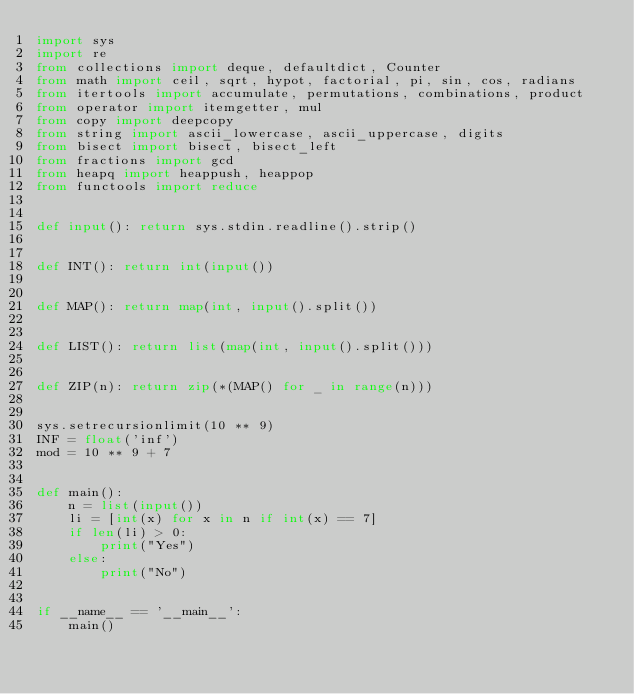Convert code to text. <code><loc_0><loc_0><loc_500><loc_500><_Python_>import sys
import re
from collections import deque, defaultdict, Counter
from math import ceil, sqrt, hypot, factorial, pi, sin, cos, radians
from itertools import accumulate, permutations, combinations, product
from operator import itemgetter, mul
from copy import deepcopy
from string import ascii_lowercase, ascii_uppercase, digits
from bisect import bisect, bisect_left
from fractions import gcd
from heapq import heappush, heappop
from functools import reduce


def input(): return sys.stdin.readline().strip()


def INT(): return int(input())


def MAP(): return map(int, input().split())


def LIST(): return list(map(int, input().split()))


def ZIP(n): return zip(*(MAP() for _ in range(n)))


sys.setrecursionlimit(10 ** 9)
INF = float('inf')
mod = 10 ** 9 + 7


def main():
    n = list(input())
    li = [int(x) for x in n if int(x) == 7]
    if len(li) > 0:
        print("Yes")
    else:
        print("No")


if __name__ == '__main__':
    main()
</code> 